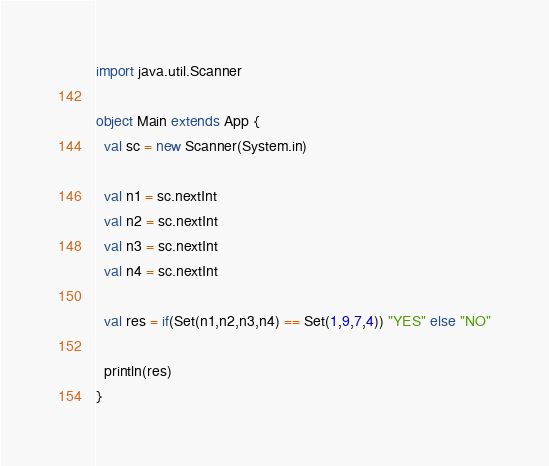<code> <loc_0><loc_0><loc_500><loc_500><_Scala_>import java.util.Scanner

object Main extends App {
  val sc = new Scanner(System.in)

  val n1 = sc.nextInt
  val n2 = sc.nextInt
  val n3 = sc.nextInt
  val n4 = sc.nextInt

  val res = if(Set(n1,n2,n3,n4) == Set(1,9,7,4)) "YES" else "NO"

  println(res)
}</code> 